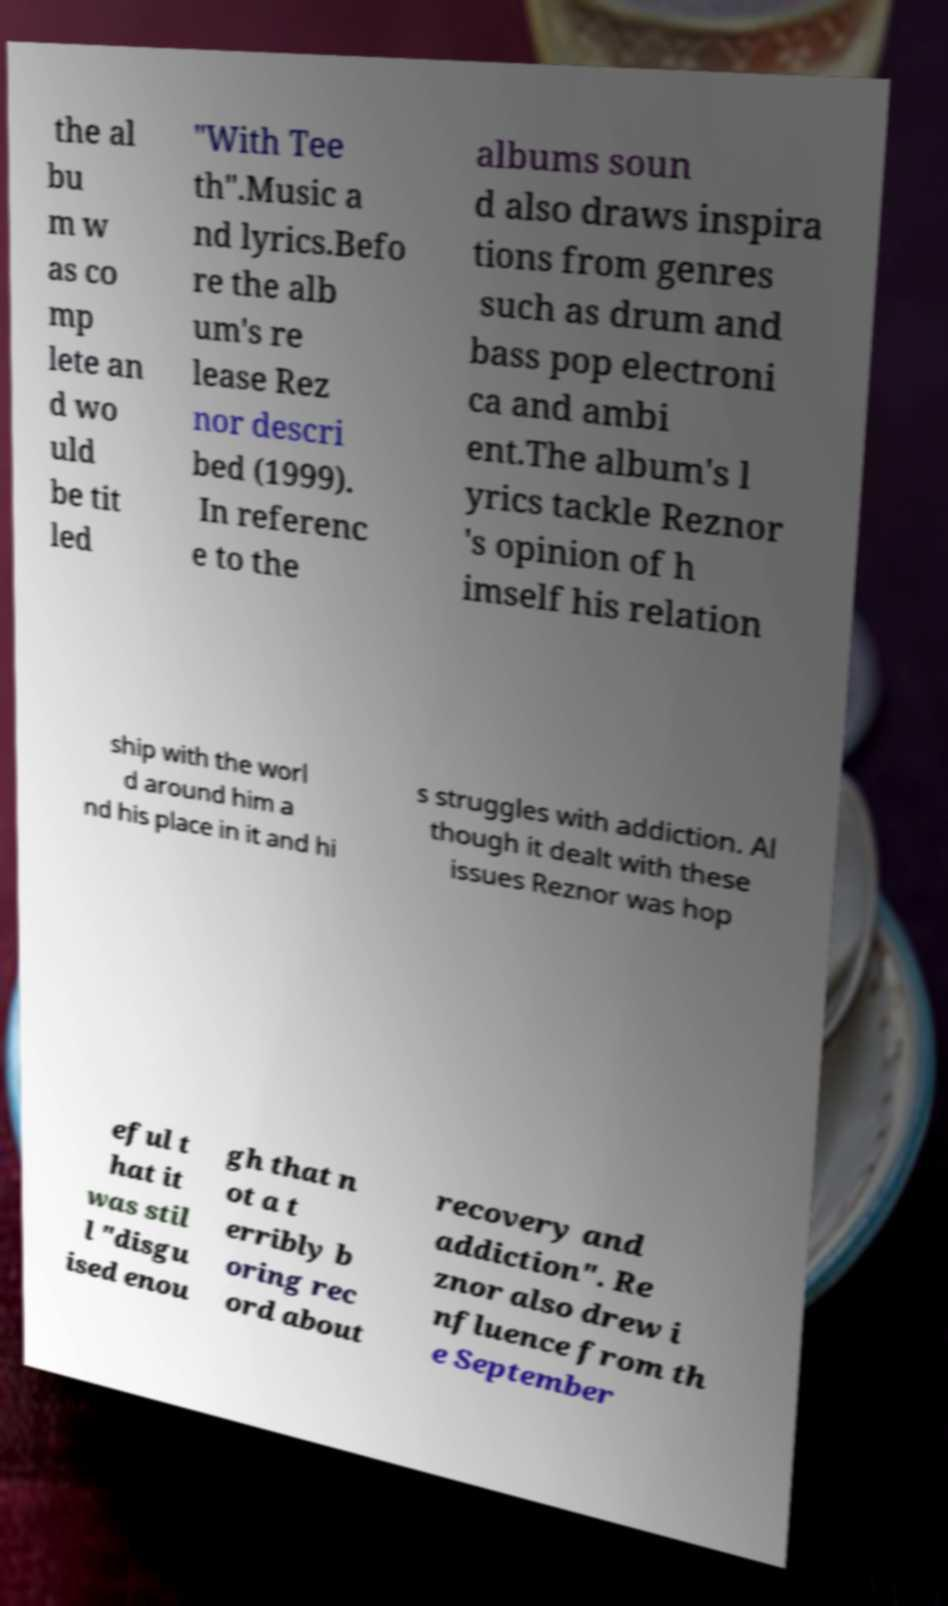For documentation purposes, I need the text within this image transcribed. Could you provide that? the al bu m w as co mp lete an d wo uld be tit led "With Tee th".Music a nd lyrics.Befo re the alb um's re lease Rez nor descri bed (1999). In referenc e to the albums soun d also draws inspira tions from genres such as drum and bass pop electroni ca and ambi ent.The album's l yrics tackle Reznor 's opinion of h imself his relation ship with the worl d around him a nd his place in it and hi s struggles with addiction. Al though it dealt with these issues Reznor was hop eful t hat it was stil l "disgu ised enou gh that n ot a t erribly b oring rec ord about recovery and addiction". Re znor also drew i nfluence from th e September 